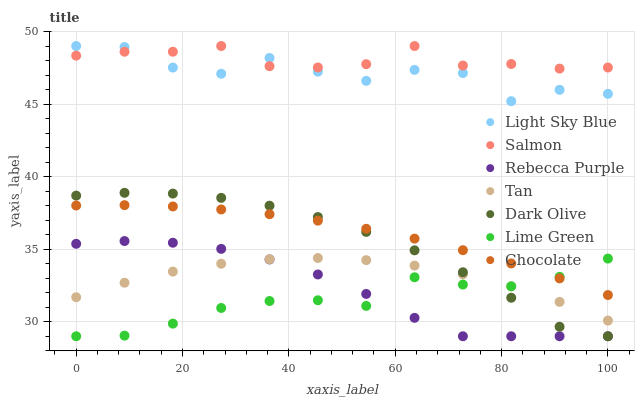Does Lime Green have the minimum area under the curve?
Answer yes or no. Yes. Does Salmon have the maximum area under the curve?
Answer yes or no. Yes. Does Chocolate have the minimum area under the curve?
Answer yes or no. No. Does Chocolate have the maximum area under the curve?
Answer yes or no. No. Is Chocolate the smoothest?
Answer yes or no. Yes. Is Light Sky Blue the roughest?
Answer yes or no. Yes. Is Salmon the smoothest?
Answer yes or no. No. Is Salmon the roughest?
Answer yes or no. No. Does Dark Olive have the lowest value?
Answer yes or no. Yes. Does Chocolate have the lowest value?
Answer yes or no. No. Does Light Sky Blue have the highest value?
Answer yes or no. Yes. Does Chocolate have the highest value?
Answer yes or no. No. Is Dark Olive less than Salmon?
Answer yes or no. Yes. Is Salmon greater than Dark Olive?
Answer yes or no. Yes. Does Rebecca Purple intersect Tan?
Answer yes or no. Yes. Is Rebecca Purple less than Tan?
Answer yes or no. No. Is Rebecca Purple greater than Tan?
Answer yes or no. No. Does Dark Olive intersect Salmon?
Answer yes or no. No. 